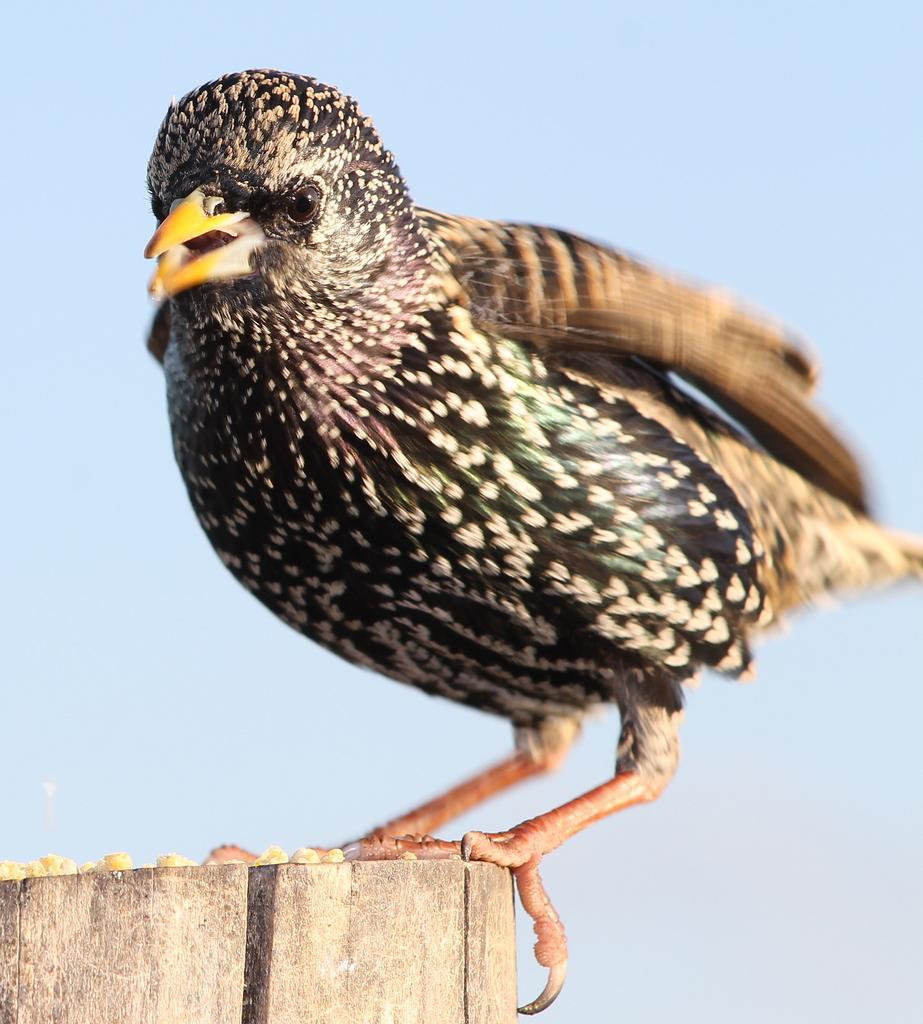Describe this image in one or two sentences. In this image there is a bird standing on a piece of wood. 